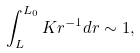Convert formula to latex. <formula><loc_0><loc_0><loc_500><loc_500>\int _ { L } ^ { L _ { 0 } } K r ^ { - 1 } d r \sim 1 ,</formula> 